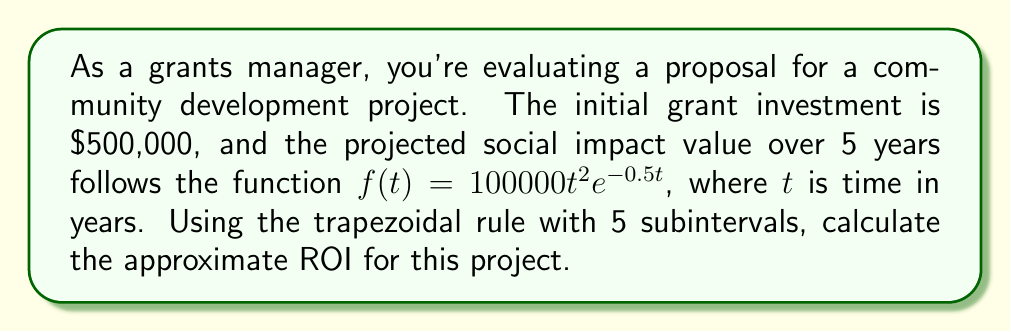Give your solution to this math problem. To solve this problem, we'll follow these steps:

1) The ROI formula is:
   $$ ROI = \frac{\text{Net Return}}{\text{Initial Investment}} \times 100\% $$

2) Net Return is the total social impact value minus the initial investment. We need to calculate the total social impact value using the trapezoidal rule.

3) The trapezoidal rule for 5 subintervals is:
   $$ \int_0^5 f(t) dt \approx \frac{h}{2}[f(0) + 2f(1) + 2f(2) + 2f(3) + 2f(4) + f(5)] $$
   where $h = \frac{5-0}{5} = 1$

4) Let's calculate the function values:
   $f(0) = 100000 \cdot 0^2 \cdot e^{-0.5 \cdot 0} = 0$
   $f(1) = 100000 \cdot 1^2 \cdot e^{-0.5 \cdot 1} \approx 60653.07$
   $f(2) = 100000 \cdot 2^2 \cdot e^{-0.5 \cdot 2} \approx 147582.35$
   $f(3) = 100000 \cdot 3^2 \cdot e^{-0.5 \cdot 3} \approx 223130.16$
   $f(4) = 100000 \cdot 4^2 \cdot e^{-0.5 \cdot 4} \approx 270670.57$
   $f(5) = 100000 \cdot 5^2 \cdot e^{-0.5 \cdot 5} \approx 297598.08$

5) Applying the trapezoidal rule:
   $$ \text{Total Impact} \approx \frac{1}{2}[0 + 2(60653.07) + 2(147582.35) + 2(223130.16) + 2(270670.57) + 297598.08] $$
   $$ = \frac{1}{2}[0 + 121306.14 + 295164.70 + 446260.32 + 541341.14 + 297598.08] $$
   $$ = \frac{1701670.38}{2} = 850835.19 $$

6) Net Return = Total Impact - Initial Investment
   $$ \text{Net Return} = 850835.19 - 500000 = 350835.19 $$

7) Finally, calculate ROI:
   $$ ROI = \frac{350835.19}{500000} \times 100\% = 70.17\% $$
Answer: The approximate ROI for this project, calculated using the trapezoidal rule with 5 subintervals, is 70.17%. 